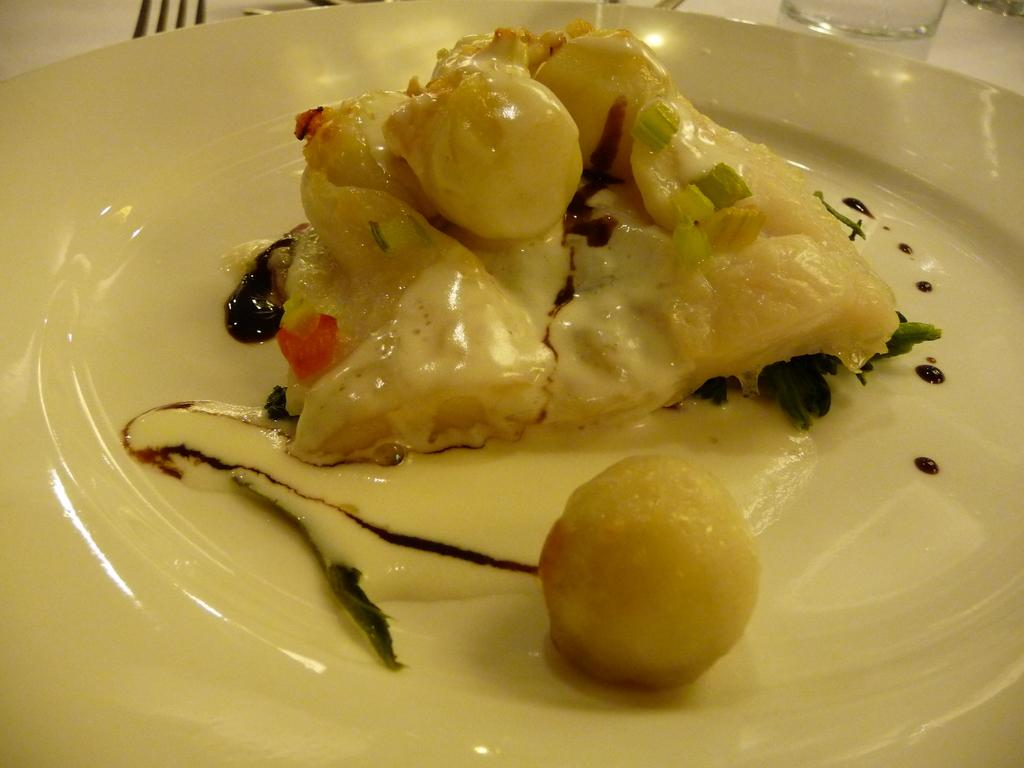What is the main food item visible on the white platter in the image? There is a food item on a white platter in the foreground of the image, but the specific type of food is not mentioned in the facts. What utensil is present in the image? There is a fork in the image. What type of container is visible in the image? There is a glass in the image. On what surface are the fork and the glass placed? The fork and the glass are on a white surface. What word is being discussed by the committee in the image? There is no mention of a committee or any discussion in the image. What type of eggnog is being served in the glass in the image? There is no eggnog present in the image; it only mentions a glass and a fork on a white surface. 